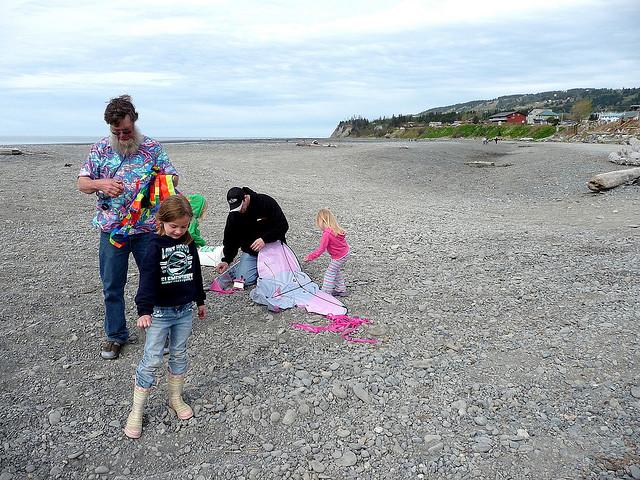How many people in this group are female?
Quick response, please. 2. Is there any children in this photo?
Keep it brief. Yes. Are these people at the beach?
Quick response, please. Yes. What are these men wearing on their bodies?
Quick response, please. Clothes. 